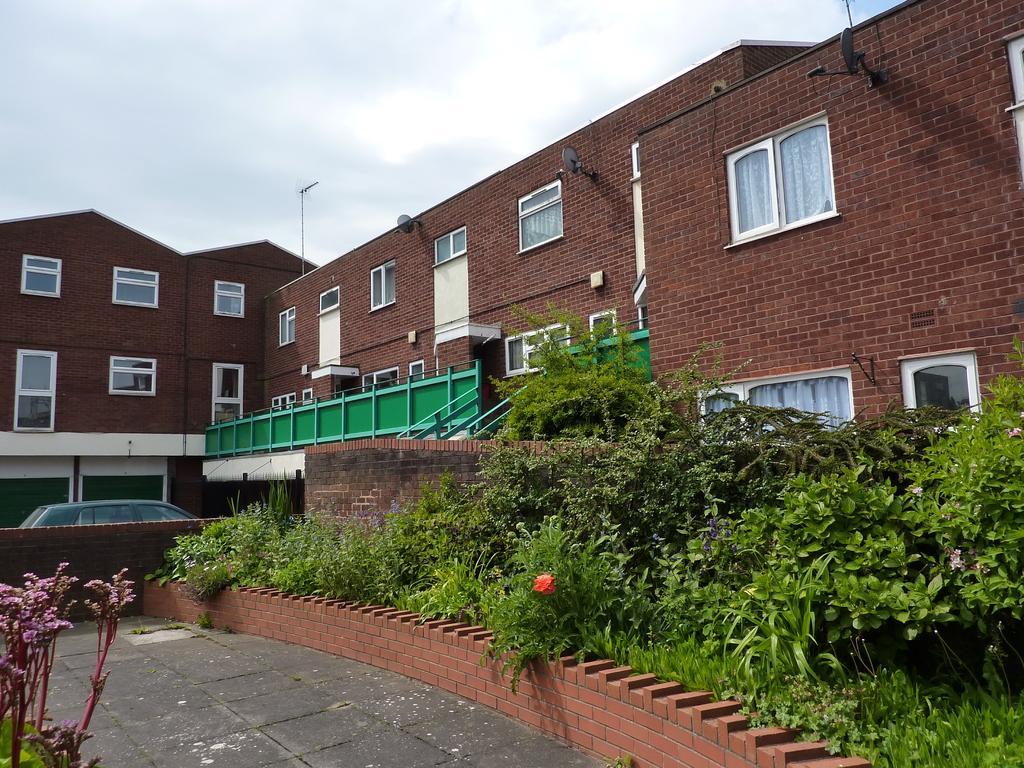Can you describe this image briefly? This picture is taken outside of the building where the plants are visible in the front with the red colour bricks wall. In the background the building is red in colour and a car in the center. On the top there is a sky and clouds. At the left side we can see a flower. 